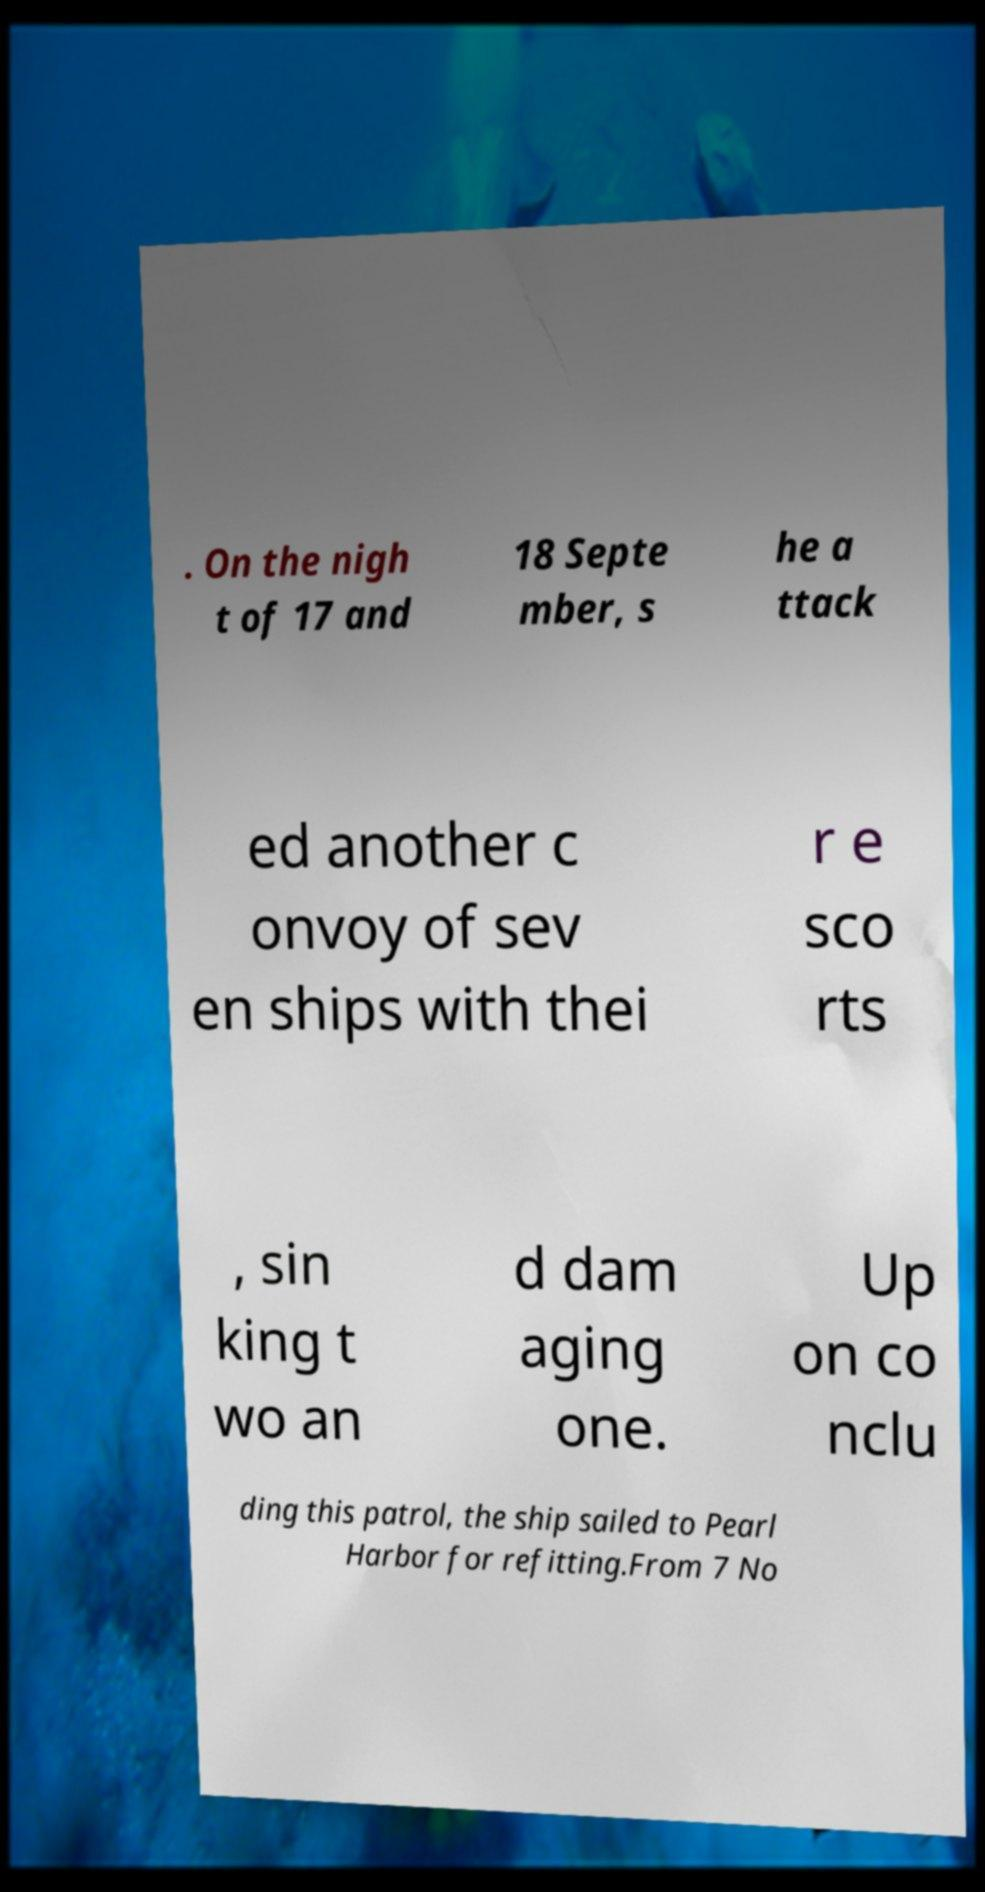Can you accurately transcribe the text from the provided image for me? . On the nigh t of 17 and 18 Septe mber, s he a ttack ed another c onvoy of sev en ships with thei r e sco rts , sin king t wo an d dam aging one. Up on co nclu ding this patrol, the ship sailed to Pearl Harbor for refitting.From 7 No 